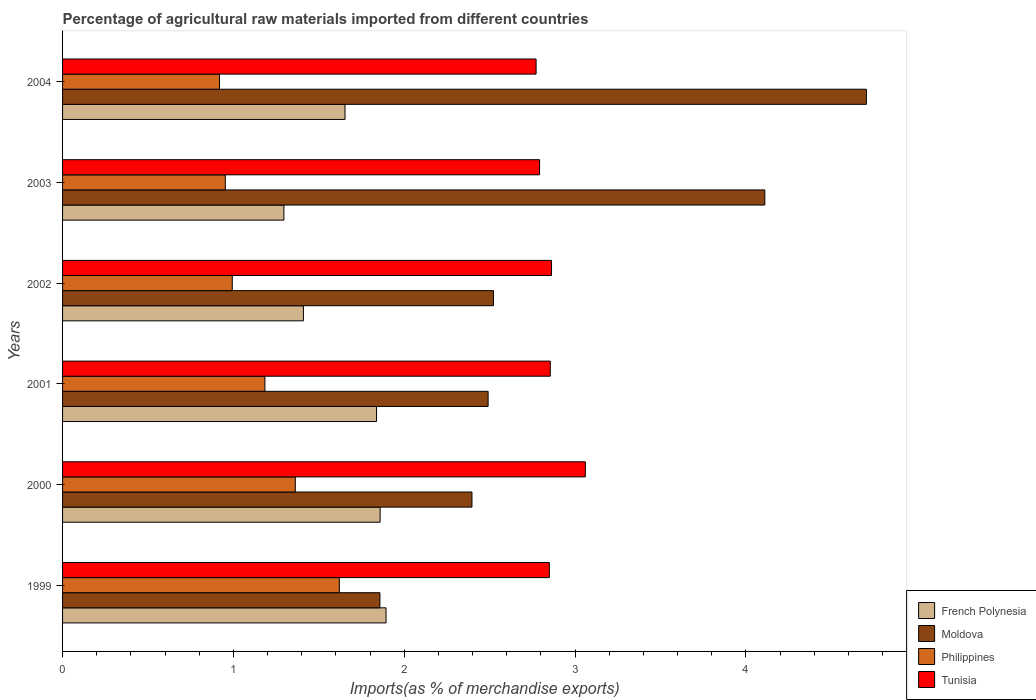Are the number of bars on each tick of the Y-axis equal?
Your response must be concise. Yes. What is the label of the 5th group of bars from the top?
Give a very brief answer. 2000. In how many cases, is the number of bars for a given year not equal to the number of legend labels?
Provide a succinct answer. 0. What is the percentage of imports to different countries in Moldova in 2004?
Offer a terse response. 4.71. Across all years, what is the maximum percentage of imports to different countries in Moldova?
Give a very brief answer. 4.71. Across all years, what is the minimum percentage of imports to different countries in French Polynesia?
Your answer should be very brief. 1.3. In which year was the percentage of imports to different countries in French Polynesia maximum?
Your answer should be compact. 1999. What is the total percentage of imports to different countries in Moldova in the graph?
Ensure brevity in your answer.  18.08. What is the difference between the percentage of imports to different countries in Philippines in 2000 and that in 2004?
Ensure brevity in your answer.  0.44. What is the difference between the percentage of imports to different countries in Tunisia in 2000 and the percentage of imports to different countries in Philippines in 2003?
Provide a short and direct response. 2.11. What is the average percentage of imports to different countries in Moldova per year?
Ensure brevity in your answer.  3.01. In the year 2002, what is the difference between the percentage of imports to different countries in French Polynesia and percentage of imports to different countries in Moldova?
Make the answer very short. -1.11. What is the ratio of the percentage of imports to different countries in Tunisia in 2002 to that in 2003?
Keep it short and to the point. 1.03. Is the percentage of imports to different countries in Philippines in 2001 less than that in 2002?
Your answer should be very brief. No. What is the difference between the highest and the second highest percentage of imports to different countries in Moldova?
Your answer should be compact. 0.59. What is the difference between the highest and the lowest percentage of imports to different countries in Moldova?
Give a very brief answer. 2.85. Is it the case that in every year, the sum of the percentage of imports to different countries in Moldova and percentage of imports to different countries in French Polynesia is greater than the sum of percentage of imports to different countries in Philippines and percentage of imports to different countries in Tunisia?
Keep it short and to the point. No. What does the 2nd bar from the top in 2004 represents?
Your response must be concise. Philippines. What does the 4th bar from the bottom in 2004 represents?
Provide a short and direct response. Tunisia. Is it the case that in every year, the sum of the percentage of imports to different countries in Tunisia and percentage of imports to different countries in French Polynesia is greater than the percentage of imports to different countries in Moldova?
Provide a short and direct response. No. How many years are there in the graph?
Give a very brief answer. 6. How are the legend labels stacked?
Provide a succinct answer. Vertical. What is the title of the graph?
Your answer should be very brief. Percentage of agricultural raw materials imported from different countries. What is the label or title of the X-axis?
Your answer should be compact. Imports(as % of merchandise exports). What is the label or title of the Y-axis?
Offer a very short reply. Years. What is the Imports(as % of merchandise exports) of French Polynesia in 1999?
Give a very brief answer. 1.89. What is the Imports(as % of merchandise exports) in Moldova in 1999?
Provide a succinct answer. 1.86. What is the Imports(as % of merchandise exports) in Philippines in 1999?
Ensure brevity in your answer.  1.62. What is the Imports(as % of merchandise exports) of Tunisia in 1999?
Offer a very short reply. 2.85. What is the Imports(as % of merchandise exports) of French Polynesia in 2000?
Provide a short and direct response. 1.86. What is the Imports(as % of merchandise exports) of Moldova in 2000?
Provide a short and direct response. 2.4. What is the Imports(as % of merchandise exports) of Philippines in 2000?
Offer a terse response. 1.36. What is the Imports(as % of merchandise exports) of Tunisia in 2000?
Your answer should be compact. 3.06. What is the Imports(as % of merchandise exports) of French Polynesia in 2001?
Your answer should be very brief. 1.84. What is the Imports(as % of merchandise exports) in Moldova in 2001?
Give a very brief answer. 2.49. What is the Imports(as % of merchandise exports) in Philippines in 2001?
Provide a succinct answer. 1.18. What is the Imports(as % of merchandise exports) in Tunisia in 2001?
Ensure brevity in your answer.  2.85. What is the Imports(as % of merchandise exports) in French Polynesia in 2002?
Your answer should be compact. 1.41. What is the Imports(as % of merchandise exports) in Moldova in 2002?
Provide a succinct answer. 2.52. What is the Imports(as % of merchandise exports) of Philippines in 2002?
Your response must be concise. 0.99. What is the Imports(as % of merchandise exports) of Tunisia in 2002?
Provide a succinct answer. 2.86. What is the Imports(as % of merchandise exports) of French Polynesia in 2003?
Ensure brevity in your answer.  1.3. What is the Imports(as % of merchandise exports) of Moldova in 2003?
Provide a succinct answer. 4.11. What is the Imports(as % of merchandise exports) of Philippines in 2003?
Your answer should be very brief. 0.95. What is the Imports(as % of merchandise exports) in Tunisia in 2003?
Provide a short and direct response. 2.79. What is the Imports(as % of merchandise exports) of French Polynesia in 2004?
Your answer should be compact. 1.65. What is the Imports(as % of merchandise exports) of Moldova in 2004?
Give a very brief answer. 4.71. What is the Imports(as % of merchandise exports) of Philippines in 2004?
Provide a short and direct response. 0.92. What is the Imports(as % of merchandise exports) in Tunisia in 2004?
Your answer should be compact. 2.77. Across all years, what is the maximum Imports(as % of merchandise exports) in French Polynesia?
Make the answer very short. 1.89. Across all years, what is the maximum Imports(as % of merchandise exports) in Moldova?
Your answer should be compact. 4.71. Across all years, what is the maximum Imports(as % of merchandise exports) of Philippines?
Offer a very short reply. 1.62. Across all years, what is the maximum Imports(as % of merchandise exports) of Tunisia?
Your response must be concise. 3.06. Across all years, what is the minimum Imports(as % of merchandise exports) of French Polynesia?
Offer a very short reply. 1.3. Across all years, what is the minimum Imports(as % of merchandise exports) of Moldova?
Make the answer very short. 1.86. Across all years, what is the minimum Imports(as % of merchandise exports) in Philippines?
Offer a terse response. 0.92. Across all years, what is the minimum Imports(as % of merchandise exports) of Tunisia?
Provide a short and direct response. 2.77. What is the total Imports(as % of merchandise exports) of French Polynesia in the graph?
Your answer should be very brief. 9.95. What is the total Imports(as % of merchandise exports) of Moldova in the graph?
Offer a very short reply. 18.08. What is the total Imports(as % of merchandise exports) of Philippines in the graph?
Your response must be concise. 7.03. What is the total Imports(as % of merchandise exports) in Tunisia in the graph?
Your answer should be very brief. 17.19. What is the difference between the Imports(as % of merchandise exports) of French Polynesia in 1999 and that in 2000?
Your response must be concise. 0.03. What is the difference between the Imports(as % of merchandise exports) in Moldova in 1999 and that in 2000?
Make the answer very short. -0.54. What is the difference between the Imports(as % of merchandise exports) of Philippines in 1999 and that in 2000?
Your answer should be very brief. 0.26. What is the difference between the Imports(as % of merchandise exports) in Tunisia in 1999 and that in 2000?
Ensure brevity in your answer.  -0.21. What is the difference between the Imports(as % of merchandise exports) in French Polynesia in 1999 and that in 2001?
Make the answer very short. 0.06. What is the difference between the Imports(as % of merchandise exports) of Moldova in 1999 and that in 2001?
Give a very brief answer. -0.63. What is the difference between the Imports(as % of merchandise exports) in Philippines in 1999 and that in 2001?
Give a very brief answer. 0.44. What is the difference between the Imports(as % of merchandise exports) in Tunisia in 1999 and that in 2001?
Your answer should be very brief. -0.01. What is the difference between the Imports(as % of merchandise exports) in French Polynesia in 1999 and that in 2002?
Your response must be concise. 0.48. What is the difference between the Imports(as % of merchandise exports) of Moldova in 1999 and that in 2002?
Give a very brief answer. -0.66. What is the difference between the Imports(as % of merchandise exports) in Philippines in 1999 and that in 2002?
Offer a terse response. 0.63. What is the difference between the Imports(as % of merchandise exports) in Tunisia in 1999 and that in 2002?
Your answer should be compact. -0.01. What is the difference between the Imports(as % of merchandise exports) in French Polynesia in 1999 and that in 2003?
Give a very brief answer. 0.6. What is the difference between the Imports(as % of merchandise exports) of Moldova in 1999 and that in 2003?
Your answer should be very brief. -2.25. What is the difference between the Imports(as % of merchandise exports) of Philippines in 1999 and that in 2003?
Give a very brief answer. 0.67. What is the difference between the Imports(as % of merchandise exports) of Tunisia in 1999 and that in 2003?
Offer a terse response. 0.06. What is the difference between the Imports(as % of merchandise exports) in French Polynesia in 1999 and that in 2004?
Your response must be concise. 0.24. What is the difference between the Imports(as % of merchandise exports) in Moldova in 1999 and that in 2004?
Your answer should be compact. -2.85. What is the difference between the Imports(as % of merchandise exports) in Philippines in 1999 and that in 2004?
Offer a terse response. 0.7. What is the difference between the Imports(as % of merchandise exports) in Tunisia in 1999 and that in 2004?
Provide a short and direct response. 0.08. What is the difference between the Imports(as % of merchandise exports) in French Polynesia in 2000 and that in 2001?
Give a very brief answer. 0.02. What is the difference between the Imports(as % of merchandise exports) in Moldova in 2000 and that in 2001?
Offer a terse response. -0.09. What is the difference between the Imports(as % of merchandise exports) in Philippines in 2000 and that in 2001?
Make the answer very short. 0.18. What is the difference between the Imports(as % of merchandise exports) in Tunisia in 2000 and that in 2001?
Ensure brevity in your answer.  0.21. What is the difference between the Imports(as % of merchandise exports) of French Polynesia in 2000 and that in 2002?
Provide a short and direct response. 0.45. What is the difference between the Imports(as % of merchandise exports) in Moldova in 2000 and that in 2002?
Your answer should be compact. -0.13. What is the difference between the Imports(as % of merchandise exports) in Philippines in 2000 and that in 2002?
Give a very brief answer. 0.37. What is the difference between the Imports(as % of merchandise exports) of Tunisia in 2000 and that in 2002?
Your answer should be very brief. 0.2. What is the difference between the Imports(as % of merchandise exports) of French Polynesia in 2000 and that in 2003?
Make the answer very short. 0.56. What is the difference between the Imports(as % of merchandise exports) of Moldova in 2000 and that in 2003?
Your answer should be very brief. -1.71. What is the difference between the Imports(as % of merchandise exports) in Philippines in 2000 and that in 2003?
Your answer should be very brief. 0.41. What is the difference between the Imports(as % of merchandise exports) of Tunisia in 2000 and that in 2003?
Your answer should be compact. 0.27. What is the difference between the Imports(as % of merchandise exports) in French Polynesia in 2000 and that in 2004?
Offer a terse response. 0.21. What is the difference between the Imports(as % of merchandise exports) of Moldova in 2000 and that in 2004?
Ensure brevity in your answer.  -2.31. What is the difference between the Imports(as % of merchandise exports) in Philippines in 2000 and that in 2004?
Offer a very short reply. 0.44. What is the difference between the Imports(as % of merchandise exports) of Tunisia in 2000 and that in 2004?
Your answer should be compact. 0.29. What is the difference between the Imports(as % of merchandise exports) in French Polynesia in 2001 and that in 2002?
Provide a succinct answer. 0.43. What is the difference between the Imports(as % of merchandise exports) in Moldova in 2001 and that in 2002?
Your response must be concise. -0.03. What is the difference between the Imports(as % of merchandise exports) in Philippines in 2001 and that in 2002?
Keep it short and to the point. 0.19. What is the difference between the Imports(as % of merchandise exports) of Tunisia in 2001 and that in 2002?
Your answer should be very brief. -0.01. What is the difference between the Imports(as % of merchandise exports) of French Polynesia in 2001 and that in 2003?
Your response must be concise. 0.54. What is the difference between the Imports(as % of merchandise exports) of Moldova in 2001 and that in 2003?
Your response must be concise. -1.62. What is the difference between the Imports(as % of merchandise exports) of Philippines in 2001 and that in 2003?
Provide a short and direct response. 0.23. What is the difference between the Imports(as % of merchandise exports) of Tunisia in 2001 and that in 2003?
Give a very brief answer. 0.06. What is the difference between the Imports(as % of merchandise exports) in French Polynesia in 2001 and that in 2004?
Your answer should be compact. 0.18. What is the difference between the Imports(as % of merchandise exports) in Moldova in 2001 and that in 2004?
Your answer should be compact. -2.21. What is the difference between the Imports(as % of merchandise exports) of Philippines in 2001 and that in 2004?
Keep it short and to the point. 0.27. What is the difference between the Imports(as % of merchandise exports) in Tunisia in 2001 and that in 2004?
Your answer should be very brief. 0.08. What is the difference between the Imports(as % of merchandise exports) of French Polynesia in 2002 and that in 2003?
Your answer should be compact. 0.11. What is the difference between the Imports(as % of merchandise exports) of Moldova in 2002 and that in 2003?
Offer a very short reply. -1.59. What is the difference between the Imports(as % of merchandise exports) of Philippines in 2002 and that in 2003?
Offer a terse response. 0.04. What is the difference between the Imports(as % of merchandise exports) in Tunisia in 2002 and that in 2003?
Your response must be concise. 0.07. What is the difference between the Imports(as % of merchandise exports) in French Polynesia in 2002 and that in 2004?
Your answer should be compact. -0.24. What is the difference between the Imports(as % of merchandise exports) in Moldova in 2002 and that in 2004?
Your answer should be very brief. -2.18. What is the difference between the Imports(as % of merchandise exports) in Philippines in 2002 and that in 2004?
Offer a terse response. 0.07. What is the difference between the Imports(as % of merchandise exports) in Tunisia in 2002 and that in 2004?
Your answer should be very brief. 0.09. What is the difference between the Imports(as % of merchandise exports) of French Polynesia in 2003 and that in 2004?
Keep it short and to the point. -0.36. What is the difference between the Imports(as % of merchandise exports) of Moldova in 2003 and that in 2004?
Provide a succinct answer. -0.59. What is the difference between the Imports(as % of merchandise exports) in Philippines in 2003 and that in 2004?
Offer a very short reply. 0.03. What is the difference between the Imports(as % of merchandise exports) of Tunisia in 2003 and that in 2004?
Your answer should be compact. 0.02. What is the difference between the Imports(as % of merchandise exports) of French Polynesia in 1999 and the Imports(as % of merchandise exports) of Moldova in 2000?
Your answer should be compact. -0.5. What is the difference between the Imports(as % of merchandise exports) in French Polynesia in 1999 and the Imports(as % of merchandise exports) in Philippines in 2000?
Keep it short and to the point. 0.53. What is the difference between the Imports(as % of merchandise exports) of French Polynesia in 1999 and the Imports(as % of merchandise exports) of Tunisia in 2000?
Offer a very short reply. -1.17. What is the difference between the Imports(as % of merchandise exports) of Moldova in 1999 and the Imports(as % of merchandise exports) of Philippines in 2000?
Provide a short and direct response. 0.5. What is the difference between the Imports(as % of merchandise exports) in Moldova in 1999 and the Imports(as % of merchandise exports) in Tunisia in 2000?
Offer a very short reply. -1.2. What is the difference between the Imports(as % of merchandise exports) of Philippines in 1999 and the Imports(as % of merchandise exports) of Tunisia in 2000?
Ensure brevity in your answer.  -1.44. What is the difference between the Imports(as % of merchandise exports) in French Polynesia in 1999 and the Imports(as % of merchandise exports) in Moldova in 2001?
Offer a very short reply. -0.6. What is the difference between the Imports(as % of merchandise exports) of French Polynesia in 1999 and the Imports(as % of merchandise exports) of Philippines in 2001?
Offer a terse response. 0.71. What is the difference between the Imports(as % of merchandise exports) in French Polynesia in 1999 and the Imports(as % of merchandise exports) in Tunisia in 2001?
Offer a terse response. -0.96. What is the difference between the Imports(as % of merchandise exports) of Moldova in 1999 and the Imports(as % of merchandise exports) of Philippines in 2001?
Make the answer very short. 0.67. What is the difference between the Imports(as % of merchandise exports) in Moldova in 1999 and the Imports(as % of merchandise exports) in Tunisia in 2001?
Ensure brevity in your answer.  -1. What is the difference between the Imports(as % of merchandise exports) in Philippines in 1999 and the Imports(as % of merchandise exports) in Tunisia in 2001?
Offer a terse response. -1.23. What is the difference between the Imports(as % of merchandise exports) of French Polynesia in 1999 and the Imports(as % of merchandise exports) of Moldova in 2002?
Offer a terse response. -0.63. What is the difference between the Imports(as % of merchandise exports) in French Polynesia in 1999 and the Imports(as % of merchandise exports) in Philippines in 2002?
Offer a terse response. 0.9. What is the difference between the Imports(as % of merchandise exports) in French Polynesia in 1999 and the Imports(as % of merchandise exports) in Tunisia in 2002?
Ensure brevity in your answer.  -0.97. What is the difference between the Imports(as % of merchandise exports) in Moldova in 1999 and the Imports(as % of merchandise exports) in Philippines in 2002?
Provide a short and direct response. 0.86. What is the difference between the Imports(as % of merchandise exports) of Moldova in 1999 and the Imports(as % of merchandise exports) of Tunisia in 2002?
Offer a terse response. -1. What is the difference between the Imports(as % of merchandise exports) in Philippines in 1999 and the Imports(as % of merchandise exports) in Tunisia in 2002?
Make the answer very short. -1.24. What is the difference between the Imports(as % of merchandise exports) in French Polynesia in 1999 and the Imports(as % of merchandise exports) in Moldova in 2003?
Offer a very short reply. -2.22. What is the difference between the Imports(as % of merchandise exports) in French Polynesia in 1999 and the Imports(as % of merchandise exports) in Philippines in 2003?
Your response must be concise. 0.94. What is the difference between the Imports(as % of merchandise exports) in French Polynesia in 1999 and the Imports(as % of merchandise exports) in Tunisia in 2003?
Offer a very short reply. -0.9. What is the difference between the Imports(as % of merchandise exports) of Moldova in 1999 and the Imports(as % of merchandise exports) of Philippines in 2003?
Your answer should be compact. 0.91. What is the difference between the Imports(as % of merchandise exports) in Moldova in 1999 and the Imports(as % of merchandise exports) in Tunisia in 2003?
Provide a succinct answer. -0.93. What is the difference between the Imports(as % of merchandise exports) of Philippines in 1999 and the Imports(as % of merchandise exports) of Tunisia in 2003?
Your answer should be very brief. -1.17. What is the difference between the Imports(as % of merchandise exports) of French Polynesia in 1999 and the Imports(as % of merchandise exports) of Moldova in 2004?
Make the answer very short. -2.81. What is the difference between the Imports(as % of merchandise exports) of French Polynesia in 1999 and the Imports(as % of merchandise exports) of Philippines in 2004?
Ensure brevity in your answer.  0.97. What is the difference between the Imports(as % of merchandise exports) in French Polynesia in 1999 and the Imports(as % of merchandise exports) in Tunisia in 2004?
Offer a terse response. -0.88. What is the difference between the Imports(as % of merchandise exports) in Moldova in 1999 and the Imports(as % of merchandise exports) in Philippines in 2004?
Offer a terse response. 0.94. What is the difference between the Imports(as % of merchandise exports) of Moldova in 1999 and the Imports(as % of merchandise exports) of Tunisia in 2004?
Your response must be concise. -0.91. What is the difference between the Imports(as % of merchandise exports) in Philippines in 1999 and the Imports(as % of merchandise exports) in Tunisia in 2004?
Keep it short and to the point. -1.15. What is the difference between the Imports(as % of merchandise exports) in French Polynesia in 2000 and the Imports(as % of merchandise exports) in Moldova in 2001?
Your answer should be very brief. -0.63. What is the difference between the Imports(as % of merchandise exports) in French Polynesia in 2000 and the Imports(as % of merchandise exports) in Philippines in 2001?
Provide a succinct answer. 0.67. What is the difference between the Imports(as % of merchandise exports) in French Polynesia in 2000 and the Imports(as % of merchandise exports) in Tunisia in 2001?
Keep it short and to the point. -1. What is the difference between the Imports(as % of merchandise exports) of Moldova in 2000 and the Imports(as % of merchandise exports) of Philippines in 2001?
Make the answer very short. 1.21. What is the difference between the Imports(as % of merchandise exports) in Moldova in 2000 and the Imports(as % of merchandise exports) in Tunisia in 2001?
Provide a succinct answer. -0.46. What is the difference between the Imports(as % of merchandise exports) in Philippines in 2000 and the Imports(as % of merchandise exports) in Tunisia in 2001?
Your answer should be compact. -1.49. What is the difference between the Imports(as % of merchandise exports) in French Polynesia in 2000 and the Imports(as % of merchandise exports) in Moldova in 2002?
Keep it short and to the point. -0.66. What is the difference between the Imports(as % of merchandise exports) in French Polynesia in 2000 and the Imports(as % of merchandise exports) in Philippines in 2002?
Provide a short and direct response. 0.87. What is the difference between the Imports(as % of merchandise exports) in French Polynesia in 2000 and the Imports(as % of merchandise exports) in Tunisia in 2002?
Your answer should be very brief. -1. What is the difference between the Imports(as % of merchandise exports) in Moldova in 2000 and the Imports(as % of merchandise exports) in Philippines in 2002?
Offer a terse response. 1.4. What is the difference between the Imports(as % of merchandise exports) in Moldova in 2000 and the Imports(as % of merchandise exports) in Tunisia in 2002?
Offer a very short reply. -0.47. What is the difference between the Imports(as % of merchandise exports) of French Polynesia in 2000 and the Imports(as % of merchandise exports) of Moldova in 2003?
Ensure brevity in your answer.  -2.25. What is the difference between the Imports(as % of merchandise exports) in French Polynesia in 2000 and the Imports(as % of merchandise exports) in Philippines in 2003?
Give a very brief answer. 0.91. What is the difference between the Imports(as % of merchandise exports) of French Polynesia in 2000 and the Imports(as % of merchandise exports) of Tunisia in 2003?
Ensure brevity in your answer.  -0.93. What is the difference between the Imports(as % of merchandise exports) of Moldova in 2000 and the Imports(as % of merchandise exports) of Philippines in 2003?
Provide a succinct answer. 1.44. What is the difference between the Imports(as % of merchandise exports) of Moldova in 2000 and the Imports(as % of merchandise exports) of Tunisia in 2003?
Give a very brief answer. -0.4. What is the difference between the Imports(as % of merchandise exports) of Philippines in 2000 and the Imports(as % of merchandise exports) of Tunisia in 2003?
Give a very brief answer. -1.43. What is the difference between the Imports(as % of merchandise exports) of French Polynesia in 2000 and the Imports(as % of merchandise exports) of Moldova in 2004?
Your answer should be compact. -2.85. What is the difference between the Imports(as % of merchandise exports) in French Polynesia in 2000 and the Imports(as % of merchandise exports) in Philippines in 2004?
Provide a succinct answer. 0.94. What is the difference between the Imports(as % of merchandise exports) in French Polynesia in 2000 and the Imports(as % of merchandise exports) in Tunisia in 2004?
Your answer should be very brief. -0.91. What is the difference between the Imports(as % of merchandise exports) of Moldova in 2000 and the Imports(as % of merchandise exports) of Philippines in 2004?
Ensure brevity in your answer.  1.48. What is the difference between the Imports(as % of merchandise exports) of Moldova in 2000 and the Imports(as % of merchandise exports) of Tunisia in 2004?
Provide a short and direct response. -0.38. What is the difference between the Imports(as % of merchandise exports) in Philippines in 2000 and the Imports(as % of merchandise exports) in Tunisia in 2004?
Your response must be concise. -1.41. What is the difference between the Imports(as % of merchandise exports) of French Polynesia in 2001 and the Imports(as % of merchandise exports) of Moldova in 2002?
Ensure brevity in your answer.  -0.68. What is the difference between the Imports(as % of merchandise exports) of French Polynesia in 2001 and the Imports(as % of merchandise exports) of Philippines in 2002?
Offer a terse response. 0.84. What is the difference between the Imports(as % of merchandise exports) of French Polynesia in 2001 and the Imports(as % of merchandise exports) of Tunisia in 2002?
Keep it short and to the point. -1.02. What is the difference between the Imports(as % of merchandise exports) in Moldova in 2001 and the Imports(as % of merchandise exports) in Philippines in 2002?
Give a very brief answer. 1.5. What is the difference between the Imports(as % of merchandise exports) of Moldova in 2001 and the Imports(as % of merchandise exports) of Tunisia in 2002?
Offer a terse response. -0.37. What is the difference between the Imports(as % of merchandise exports) in Philippines in 2001 and the Imports(as % of merchandise exports) in Tunisia in 2002?
Ensure brevity in your answer.  -1.68. What is the difference between the Imports(as % of merchandise exports) of French Polynesia in 2001 and the Imports(as % of merchandise exports) of Moldova in 2003?
Your answer should be compact. -2.27. What is the difference between the Imports(as % of merchandise exports) in French Polynesia in 2001 and the Imports(as % of merchandise exports) in Philippines in 2003?
Give a very brief answer. 0.89. What is the difference between the Imports(as % of merchandise exports) in French Polynesia in 2001 and the Imports(as % of merchandise exports) in Tunisia in 2003?
Offer a very short reply. -0.95. What is the difference between the Imports(as % of merchandise exports) of Moldova in 2001 and the Imports(as % of merchandise exports) of Philippines in 2003?
Provide a short and direct response. 1.54. What is the difference between the Imports(as % of merchandise exports) in Moldova in 2001 and the Imports(as % of merchandise exports) in Tunisia in 2003?
Keep it short and to the point. -0.3. What is the difference between the Imports(as % of merchandise exports) in Philippines in 2001 and the Imports(as % of merchandise exports) in Tunisia in 2003?
Ensure brevity in your answer.  -1.61. What is the difference between the Imports(as % of merchandise exports) of French Polynesia in 2001 and the Imports(as % of merchandise exports) of Moldova in 2004?
Give a very brief answer. -2.87. What is the difference between the Imports(as % of merchandise exports) of French Polynesia in 2001 and the Imports(as % of merchandise exports) of Philippines in 2004?
Your response must be concise. 0.92. What is the difference between the Imports(as % of merchandise exports) of French Polynesia in 2001 and the Imports(as % of merchandise exports) of Tunisia in 2004?
Your answer should be very brief. -0.93. What is the difference between the Imports(as % of merchandise exports) of Moldova in 2001 and the Imports(as % of merchandise exports) of Philippines in 2004?
Provide a succinct answer. 1.57. What is the difference between the Imports(as % of merchandise exports) of Moldova in 2001 and the Imports(as % of merchandise exports) of Tunisia in 2004?
Your answer should be very brief. -0.28. What is the difference between the Imports(as % of merchandise exports) of Philippines in 2001 and the Imports(as % of merchandise exports) of Tunisia in 2004?
Your answer should be compact. -1.59. What is the difference between the Imports(as % of merchandise exports) in French Polynesia in 2002 and the Imports(as % of merchandise exports) in Moldova in 2003?
Your answer should be very brief. -2.7. What is the difference between the Imports(as % of merchandise exports) of French Polynesia in 2002 and the Imports(as % of merchandise exports) of Philippines in 2003?
Your answer should be very brief. 0.46. What is the difference between the Imports(as % of merchandise exports) of French Polynesia in 2002 and the Imports(as % of merchandise exports) of Tunisia in 2003?
Your response must be concise. -1.38. What is the difference between the Imports(as % of merchandise exports) of Moldova in 2002 and the Imports(as % of merchandise exports) of Philippines in 2003?
Offer a terse response. 1.57. What is the difference between the Imports(as % of merchandise exports) in Moldova in 2002 and the Imports(as % of merchandise exports) in Tunisia in 2003?
Provide a succinct answer. -0.27. What is the difference between the Imports(as % of merchandise exports) in Philippines in 2002 and the Imports(as % of merchandise exports) in Tunisia in 2003?
Keep it short and to the point. -1.8. What is the difference between the Imports(as % of merchandise exports) in French Polynesia in 2002 and the Imports(as % of merchandise exports) in Moldova in 2004?
Your response must be concise. -3.3. What is the difference between the Imports(as % of merchandise exports) of French Polynesia in 2002 and the Imports(as % of merchandise exports) of Philippines in 2004?
Provide a short and direct response. 0.49. What is the difference between the Imports(as % of merchandise exports) in French Polynesia in 2002 and the Imports(as % of merchandise exports) in Tunisia in 2004?
Make the answer very short. -1.36. What is the difference between the Imports(as % of merchandise exports) of Moldova in 2002 and the Imports(as % of merchandise exports) of Philippines in 2004?
Ensure brevity in your answer.  1.6. What is the difference between the Imports(as % of merchandise exports) of Moldova in 2002 and the Imports(as % of merchandise exports) of Tunisia in 2004?
Offer a terse response. -0.25. What is the difference between the Imports(as % of merchandise exports) of Philippines in 2002 and the Imports(as % of merchandise exports) of Tunisia in 2004?
Give a very brief answer. -1.78. What is the difference between the Imports(as % of merchandise exports) of French Polynesia in 2003 and the Imports(as % of merchandise exports) of Moldova in 2004?
Give a very brief answer. -3.41. What is the difference between the Imports(as % of merchandise exports) of French Polynesia in 2003 and the Imports(as % of merchandise exports) of Philippines in 2004?
Give a very brief answer. 0.38. What is the difference between the Imports(as % of merchandise exports) of French Polynesia in 2003 and the Imports(as % of merchandise exports) of Tunisia in 2004?
Ensure brevity in your answer.  -1.48. What is the difference between the Imports(as % of merchandise exports) in Moldova in 2003 and the Imports(as % of merchandise exports) in Philippines in 2004?
Your answer should be compact. 3.19. What is the difference between the Imports(as % of merchandise exports) of Moldova in 2003 and the Imports(as % of merchandise exports) of Tunisia in 2004?
Give a very brief answer. 1.34. What is the difference between the Imports(as % of merchandise exports) of Philippines in 2003 and the Imports(as % of merchandise exports) of Tunisia in 2004?
Provide a short and direct response. -1.82. What is the average Imports(as % of merchandise exports) in French Polynesia per year?
Your answer should be compact. 1.66. What is the average Imports(as % of merchandise exports) of Moldova per year?
Offer a terse response. 3.01. What is the average Imports(as % of merchandise exports) of Philippines per year?
Give a very brief answer. 1.17. What is the average Imports(as % of merchandise exports) in Tunisia per year?
Your answer should be compact. 2.87. In the year 1999, what is the difference between the Imports(as % of merchandise exports) in French Polynesia and Imports(as % of merchandise exports) in Moldova?
Provide a short and direct response. 0.04. In the year 1999, what is the difference between the Imports(as % of merchandise exports) of French Polynesia and Imports(as % of merchandise exports) of Philippines?
Your answer should be compact. 0.27. In the year 1999, what is the difference between the Imports(as % of merchandise exports) in French Polynesia and Imports(as % of merchandise exports) in Tunisia?
Offer a very short reply. -0.96. In the year 1999, what is the difference between the Imports(as % of merchandise exports) in Moldova and Imports(as % of merchandise exports) in Philippines?
Your answer should be very brief. 0.24. In the year 1999, what is the difference between the Imports(as % of merchandise exports) in Moldova and Imports(as % of merchandise exports) in Tunisia?
Ensure brevity in your answer.  -0.99. In the year 1999, what is the difference between the Imports(as % of merchandise exports) in Philippines and Imports(as % of merchandise exports) in Tunisia?
Offer a very short reply. -1.23. In the year 2000, what is the difference between the Imports(as % of merchandise exports) in French Polynesia and Imports(as % of merchandise exports) in Moldova?
Your answer should be very brief. -0.54. In the year 2000, what is the difference between the Imports(as % of merchandise exports) in French Polynesia and Imports(as % of merchandise exports) in Philippines?
Offer a terse response. 0.5. In the year 2000, what is the difference between the Imports(as % of merchandise exports) of French Polynesia and Imports(as % of merchandise exports) of Tunisia?
Your answer should be very brief. -1.2. In the year 2000, what is the difference between the Imports(as % of merchandise exports) of Moldova and Imports(as % of merchandise exports) of Philippines?
Your answer should be compact. 1.03. In the year 2000, what is the difference between the Imports(as % of merchandise exports) of Moldova and Imports(as % of merchandise exports) of Tunisia?
Offer a terse response. -0.66. In the year 2000, what is the difference between the Imports(as % of merchandise exports) in Philippines and Imports(as % of merchandise exports) in Tunisia?
Provide a short and direct response. -1.7. In the year 2001, what is the difference between the Imports(as % of merchandise exports) in French Polynesia and Imports(as % of merchandise exports) in Moldova?
Keep it short and to the point. -0.65. In the year 2001, what is the difference between the Imports(as % of merchandise exports) of French Polynesia and Imports(as % of merchandise exports) of Philippines?
Your answer should be very brief. 0.65. In the year 2001, what is the difference between the Imports(as % of merchandise exports) of French Polynesia and Imports(as % of merchandise exports) of Tunisia?
Offer a very short reply. -1.02. In the year 2001, what is the difference between the Imports(as % of merchandise exports) in Moldova and Imports(as % of merchandise exports) in Philippines?
Keep it short and to the point. 1.31. In the year 2001, what is the difference between the Imports(as % of merchandise exports) of Moldova and Imports(as % of merchandise exports) of Tunisia?
Your answer should be very brief. -0.36. In the year 2001, what is the difference between the Imports(as % of merchandise exports) in Philippines and Imports(as % of merchandise exports) in Tunisia?
Ensure brevity in your answer.  -1.67. In the year 2002, what is the difference between the Imports(as % of merchandise exports) in French Polynesia and Imports(as % of merchandise exports) in Moldova?
Provide a succinct answer. -1.11. In the year 2002, what is the difference between the Imports(as % of merchandise exports) of French Polynesia and Imports(as % of merchandise exports) of Philippines?
Provide a succinct answer. 0.42. In the year 2002, what is the difference between the Imports(as % of merchandise exports) of French Polynesia and Imports(as % of merchandise exports) of Tunisia?
Offer a terse response. -1.45. In the year 2002, what is the difference between the Imports(as % of merchandise exports) of Moldova and Imports(as % of merchandise exports) of Philippines?
Keep it short and to the point. 1.53. In the year 2002, what is the difference between the Imports(as % of merchandise exports) in Moldova and Imports(as % of merchandise exports) in Tunisia?
Offer a very short reply. -0.34. In the year 2002, what is the difference between the Imports(as % of merchandise exports) of Philippines and Imports(as % of merchandise exports) of Tunisia?
Your answer should be very brief. -1.87. In the year 2003, what is the difference between the Imports(as % of merchandise exports) of French Polynesia and Imports(as % of merchandise exports) of Moldova?
Your answer should be very brief. -2.81. In the year 2003, what is the difference between the Imports(as % of merchandise exports) in French Polynesia and Imports(as % of merchandise exports) in Philippines?
Keep it short and to the point. 0.34. In the year 2003, what is the difference between the Imports(as % of merchandise exports) of French Polynesia and Imports(as % of merchandise exports) of Tunisia?
Make the answer very short. -1.5. In the year 2003, what is the difference between the Imports(as % of merchandise exports) in Moldova and Imports(as % of merchandise exports) in Philippines?
Your answer should be very brief. 3.16. In the year 2003, what is the difference between the Imports(as % of merchandise exports) of Moldova and Imports(as % of merchandise exports) of Tunisia?
Give a very brief answer. 1.32. In the year 2003, what is the difference between the Imports(as % of merchandise exports) in Philippines and Imports(as % of merchandise exports) in Tunisia?
Give a very brief answer. -1.84. In the year 2004, what is the difference between the Imports(as % of merchandise exports) in French Polynesia and Imports(as % of merchandise exports) in Moldova?
Keep it short and to the point. -3.05. In the year 2004, what is the difference between the Imports(as % of merchandise exports) in French Polynesia and Imports(as % of merchandise exports) in Philippines?
Provide a succinct answer. 0.73. In the year 2004, what is the difference between the Imports(as % of merchandise exports) of French Polynesia and Imports(as % of merchandise exports) of Tunisia?
Your answer should be very brief. -1.12. In the year 2004, what is the difference between the Imports(as % of merchandise exports) in Moldova and Imports(as % of merchandise exports) in Philippines?
Provide a succinct answer. 3.79. In the year 2004, what is the difference between the Imports(as % of merchandise exports) in Moldova and Imports(as % of merchandise exports) in Tunisia?
Keep it short and to the point. 1.93. In the year 2004, what is the difference between the Imports(as % of merchandise exports) of Philippines and Imports(as % of merchandise exports) of Tunisia?
Keep it short and to the point. -1.85. What is the ratio of the Imports(as % of merchandise exports) of French Polynesia in 1999 to that in 2000?
Your answer should be very brief. 1.02. What is the ratio of the Imports(as % of merchandise exports) of Moldova in 1999 to that in 2000?
Your response must be concise. 0.78. What is the ratio of the Imports(as % of merchandise exports) in Philippines in 1999 to that in 2000?
Give a very brief answer. 1.19. What is the ratio of the Imports(as % of merchandise exports) of Tunisia in 1999 to that in 2000?
Keep it short and to the point. 0.93. What is the ratio of the Imports(as % of merchandise exports) in French Polynesia in 1999 to that in 2001?
Offer a very short reply. 1.03. What is the ratio of the Imports(as % of merchandise exports) of Moldova in 1999 to that in 2001?
Your response must be concise. 0.75. What is the ratio of the Imports(as % of merchandise exports) in Philippines in 1999 to that in 2001?
Your answer should be compact. 1.37. What is the ratio of the Imports(as % of merchandise exports) of French Polynesia in 1999 to that in 2002?
Your answer should be compact. 1.34. What is the ratio of the Imports(as % of merchandise exports) in Moldova in 1999 to that in 2002?
Offer a terse response. 0.74. What is the ratio of the Imports(as % of merchandise exports) in Philippines in 1999 to that in 2002?
Provide a succinct answer. 1.63. What is the ratio of the Imports(as % of merchandise exports) of French Polynesia in 1999 to that in 2003?
Keep it short and to the point. 1.46. What is the ratio of the Imports(as % of merchandise exports) of Moldova in 1999 to that in 2003?
Provide a short and direct response. 0.45. What is the ratio of the Imports(as % of merchandise exports) in Philippines in 1999 to that in 2003?
Offer a terse response. 1.7. What is the ratio of the Imports(as % of merchandise exports) of Tunisia in 1999 to that in 2003?
Provide a short and direct response. 1.02. What is the ratio of the Imports(as % of merchandise exports) of French Polynesia in 1999 to that in 2004?
Your answer should be very brief. 1.15. What is the ratio of the Imports(as % of merchandise exports) in Moldova in 1999 to that in 2004?
Give a very brief answer. 0.39. What is the ratio of the Imports(as % of merchandise exports) of Philippines in 1999 to that in 2004?
Provide a succinct answer. 1.76. What is the ratio of the Imports(as % of merchandise exports) of Tunisia in 1999 to that in 2004?
Provide a succinct answer. 1.03. What is the ratio of the Imports(as % of merchandise exports) of French Polynesia in 2000 to that in 2001?
Offer a terse response. 1.01. What is the ratio of the Imports(as % of merchandise exports) in Moldova in 2000 to that in 2001?
Ensure brevity in your answer.  0.96. What is the ratio of the Imports(as % of merchandise exports) in Philippines in 2000 to that in 2001?
Your answer should be very brief. 1.15. What is the ratio of the Imports(as % of merchandise exports) of Tunisia in 2000 to that in 2001?
Your response must be concise. 1.07. What is the ratio of the Imports(as % of merchandise exports) in French Polynesia in 2000 to that in 2002?
Your answer should be very brief. 1.32. What is the ratio of the Imports(as % of merchandise exports) in Moldova in 2000 to that in 2002?
Offer a terse response. 0.95. What is the ratio of the Imports(as % of merchandise exports) of Philippines in 2000 to that in 2002?
Your answer should be very brief. 1.37. What is the ratio of the Imports(as % of merchandise exports) of Tunisia in 2000 to that in 2002?
Offer a very short reply. 1.07. What is the ratio of the Imports(as % of merchandise exports) in French Polynesia in 2000 to that in 2003?
Ensure brevity in your answer.  1.43. What is the ratio of the Imports(as % of merchandise exports) of Moldova in 2000 to that in 2003?
Make the answer very short. 0.58. What is the ratio of the Imports(as % of merchandise exports) of Philippines in 2000 to that in 2003?
Make the answer very short. 1.43. What is the ratio of the Imports(as % of merchandise exports) in Tunisia in 2000 to that in 2003?
Provide a succinct answer. 1.1. What is the ratio of the Imports(as % of merchandise exports) of French Polynesia in 2000 to that in 2004?
Your answer should be very brief. 1.12. What is the ratio of the Imports(as % of merchandise exports) in Moldova in 2000 to that in 2004?
Keep it short and to the point. 0.51. What is the ratio of the Imports(as % of merchandise exports) in Philippines in 2000 to that in 2004?
Make the answer very short. 1.48. What is the ratio of the Imports(as % of merchandise exports) in Tunisia in 2000 to that in 2004?
Offer a very short reply. 1.1. What is the ratio of the Imports(as % of merchandise exports) of French Polynesia in 2001 to that in 2002?
Give a very brief answer. 1.3. What is the ratio of the Imports(as % of merchandise exports) in Moldova in 2001 to that in 2002?
Your response must be concise. 0.99. What is the ratio of the Imports(as % of merchandise exports) in Philippines in 2001 to that in 2002?
Your answer should be very brief. 1.19. What is the ratio of the Imports(as % of merchandise exports) of French Polynesia in 2001 to that in 2003?
Your answer should be very brief. 1.42. What is the ratio of the Imports(as % of merchandise exports) in Moldova in 2001 to that in 2003?
Offer a terse response. 0.61. What is the ratio of the Imports(as % of merchandise exports) of Philippines in 2001 to that in 2003?
Ensure brevity in your answer.  1.24. What is the ratio of the Imports(as % of merchandise exports) in Tunisia in 2001 to that in 2003?
Offer a very short reply. 1.02. What is the ratio of the Imports(as % of merchandise exports) in French Polynesia in 2001 to that in 2004?
Provide a succinct answer. 1.11. What is the ratio of the Imports(as % of merchandise exports) of Moldova in 2001 to that in 2004?
Your answer should be very brief. 0.53. What is the ratio of the Imports(as % of merchandise exports) in Philippines in 2001 to that in 2004?
Keep it short and to the point. 1.29. What is the ratio of the Imports(as % of merchandise exports) of French Polynesia in 2002 to that in 2003?
Ensure brevity in your answer.  1.09. What is the ratio of the Imports(as % of merchandise exports) in Moldova in 2002 to that in 2003?
Your answer should be compact. 0.61. What is the ratio of the Imports(as % of merchandise exports) in Philippines in 2002 to that in 2003?
Ensure brevity in your answer.  1.04. What is the ratio of the Imports(as % of merchandise exports) of Tunisia in 2002 to that in 2003?
Provide a succinct answer. 1.02. What is the ratio of the Imports(as % of merchandise exports) in French Polynesia in 2002 to that in 2004?
Provide a short and direct response. 0.85. What is the ratio of the Imports(as % of merchandise exports) in Moldova in 2002 to that in 2004?
Your answer should be very brief. 0.54. What is the ratio of the Imports(as % of merchandise exports) in Philippines in 2002 to that in 2004?
Your answer should be compact. 1.08. What is the ratio of the Imports(as % of merchandise exports) of Tunisia in 2002 to that in 2004?
Offer a very short reply. 1.03. What is the ratio of the Imports(as % of merchandise exports) of French Polynesia in 2003 to that in 2004?
Offer a terse response. 0.78. What is the ratio of the Imports(as % of merchandise exports) in Moldova in 2003 to that in 2004?
Your response must be concise. 0.87. What is the ratio of the Imports(as % of merchandise exports) of Philippines in 2003 to that in 2004?
Give a very brief answer. 1.04. What is the ratio of the Imports(as % of merchandise exports) in Tunisia in 2003 to that in 2004?
Your answer should be very brief. 1.01. What is the difference between the highest and the second highest Imports(as % of merchandise exports) in French Polynesia?
Ensure brevity in your answer.  0.03. What is the difference between the highest and the second highest Imports(as % of merchandise exports) of Moldova?
Your answer should be compact. 0.59. What is the difference between the highest and the second highest Imports(as % of merchandise exports) in Philippines?
Your answer should be compact. 0.26. What is the difference between the highest and the second highest Imports(as % of merchandise exports) of Tunisia?
Offer a terse response. 0.2. What is the difference between the highest and the lowest Imports(as % of merchandise exports) of French Polynesia?
Your answer should be compact. 0.6. What is the difference between the highest and the lowest Imports(as % of merchandise exports) in Moldova?
Your answer should be very brief. 2.85. What is the difference between the highest and the lowest Imports(as % of merchandise exports) of Philippines?
Give a very brief answer. 0.7. What is the difference between the highest and the lowest Imports(as % of merchandise exports) in Tunisia?
Offer a terse response. 0.29. 